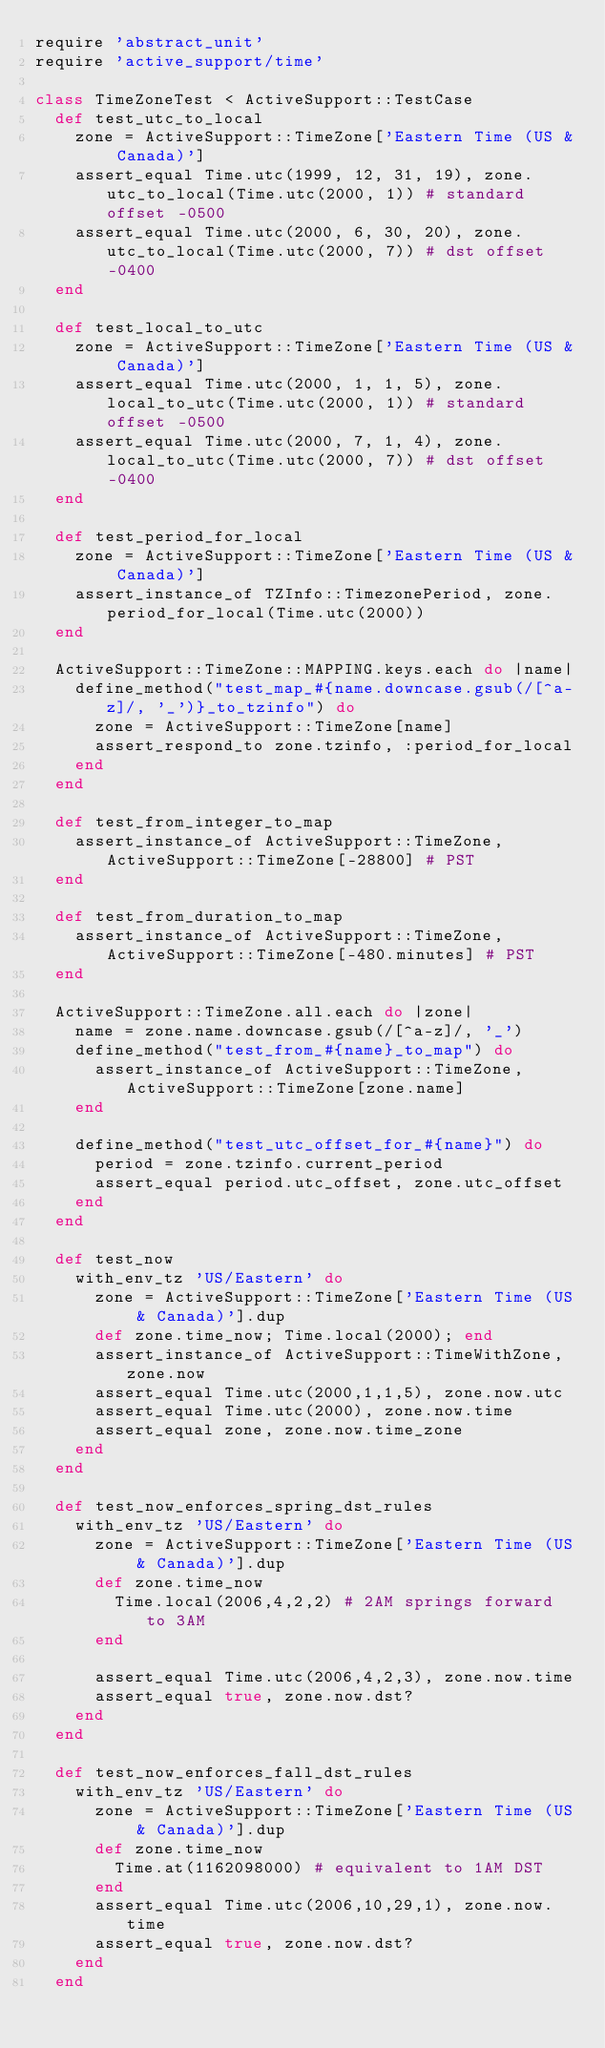Convert code to text. <code><loc_0><loc_0><loc_500><loc_500><_Ruby_>require 'abstract_unit'
require 'active_support/time'

class TimeZoneTest < ActiveSupport::TestCase
  def test_utc_to_local
    zone = ActiveSupport::TimeZone['Eastern Time (US & Canada)']
    assert_equal Time.utc(1999, 12, 31, 19), zone.utc_to_local(Time.utc(2000, 1)) # standard offset -0500
    assert_equal Time.utc(2000, 6, 30, 20), zone.utc_to_local(Time.utc(2000, 7)) # dst offset -0400
  end

  def test_local_to_utc
    zone = ActiveSupport::TimeZone['Eastern Time (US & Canada)']
    assert_equal Time.utc(2000, 1, 1, 5), zone.local_to_utc(Time.utc(2000, 1)) # standard offset -0500
    assert_equal Time.utc(2000, 7, 1, 4), zone.local_to_utc(Time.utc(2000, 7)) # dst offset -0400
  end

  def test_period_for_local
    zone = ActiveSupport::TimeZone['Eastern Time (US & Canada)']
    assert_instance_of TZInfo::TimezonePeriod, zone.period_for_local(Time.utc(2000))
  end

  ActiveSupport::TimeZone::MAPPING.keys.each do |name|
    define_method("test_map_#{name.downcase.gsub(/[^a-z]/, '_')}_to_tzinfo") do
      zone = ActiveSupport::TimeZone[name]
      assert_respond_to zone.tzinfo, :period_for_local
    end
  end

  def test_from_integer_to_map
    assert_instance_of ActiveSupport::TimeZone, ActiveSupport::TimeZone[-28800] # PST
  end

  def test_from_duration_to_map
    assert_instance_of ActiveSupport::TimeZone, ActiveSupport::TimeZone[-480.minutes] # PST
  end

  ActiveSupport::TimeZone.all.each do |zone|
    name = zone.name.downcase.gsub(/[^a-z]/, '_')
    define_method("test_from_#{name}_to_map") do
      assert_instance_of ActiveSupport::TimeZone, ActiveSupport::TimeZone[zone.name]
    end

    define_method("test_utc_offset_for_#{name}") do
      period = zone.tzinfo.current_period
      assert_equal period.utc_offset, zone.utc_offset
    end
  end

  def test_now
    with_env_tz 'US/Eastern' do
      zone = ActiveSupport::TimeZone['Eastern Time (US & Canada)'].dup
      def zone.time_now; Time.local(2000); end
      assert_instance_of ActiveSupport::TimeWithZone, zone.now
      assert_equal Time.utc(2000,1,1,5), zone.now.utc
      assert_equal Time.utc(2000), zone.now.time
      assert_equal zone, zone.now.time_zone
    end
  end

  def test_now_enforces_spring_dst_rules
    with_env_tz 'US/Eastern' do
      zone = ActiveSupport::TimeZone['Eastern Time (US & Canada)'].dup
      def zone.time_now
        Time.local(2006,4,2,2) # 2AM springs forward to 3AM
      end

      assert_equal Time.utc(2006,4,2,3), zone.now.time
      assert_equal true, zone.now.dst?
    end
  end

  def test_now_enforces_fall_dst_rules
    with_env_tz 'US/Eastern' do
      zone = ActiveSupport::TimeZone['Eastern Time (US & Canada)'].dup
      def zone.time_now
        Time.at(1162098000) # equivalent to 1AM DST
      end
      assert_equal Time.utc(2006,10,29,1), zone.now.time
      assert_equal true, zone.now.dst?
    end
  end
</code> 